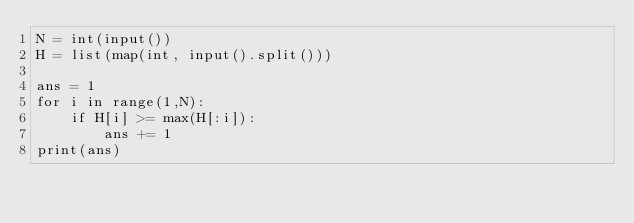<code> <loc_0><loc_0><loc_500><loc_500><_Python_>N = int(input())
H = list(map(int, input().split()))

ans = 1 
for i in range(1,N):
    if H[i] >= max(H[:i]):
        ans += 1
print(ans)</code> 